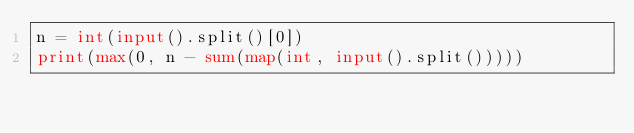<code> <loc_0><loc_0><loc_500><loc_500><_Python_>n = int(input().split()[0])
print(max(0, n - sum(map(int, input().split()))))</code> 